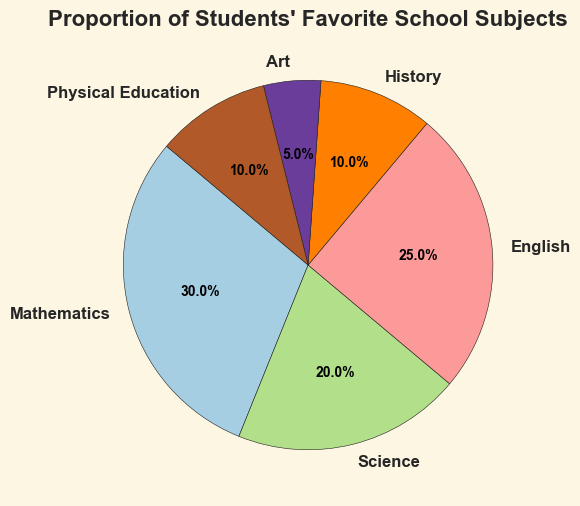Which subject has the highest proportion of students favoring it? By looking at the pie chart, the subject with the largest slice represents the highest proportion. It shows that Mathematics has the largest slice.
Answer: Mathematics What is the total proportion of students who favor either Mathematics or English? Adding the proportions of Mathematics and English directly from the chart: 30 (Mathematics) + 25 (English) = 55.
Answer: 55 How does the proportion of students favoring Physical Education compare to those favoring History? By comparing the sizes of the slices for Physical Education and History. They look equal, at 10.
Answer: Equal What is the difference in proportion between students who favor Science and those who favor Art? Subtract the proportion of Art from the proportion of Science directly from the chart: 20 (Science) - 5 (Art) = 15.
Answer: 15 Which subject has the smallest proportion of students favoring it? By looking at the pie chart, the subject with the smallest slice represents the smallest proportion. It shows that Art has the smallest slice.
Answer: Art What's the combined proportion of students favoring History and Physical Education compared to Science? First, add History and Physical Education: 10 + 10 = 20. Second, compare with Science: 20 (History + Physical Education) vs. 20 (Science). They are the same.
Answer: Same What is the proportion of students favoring the three subjects with the highest proportions? Identifying subjects with highest proportions by looking at the size of slices: Mathematics (30), English (25), and Science (20). Add these: 30 + 25 + 20 = 75.
Answer: 75 Which subject's slice appears in purple on the pie chart? By looking at the colors of the slices in the pie chart, the purple slice represents History.
Answer: History Considering only Mathematics and Science, how many percentage points more is Mathematics favored than Science? Subtract the proportion of Science from the proportion of Mathematics directly from the chart: 30 (Mathematics) - 20 (Science) = 10.
Answer: 10 Which subject's slice is largest after Mathematics? By visual inspection of the pie chart, the next largest slice after Mathematics is the slice for English.
Answer: English 